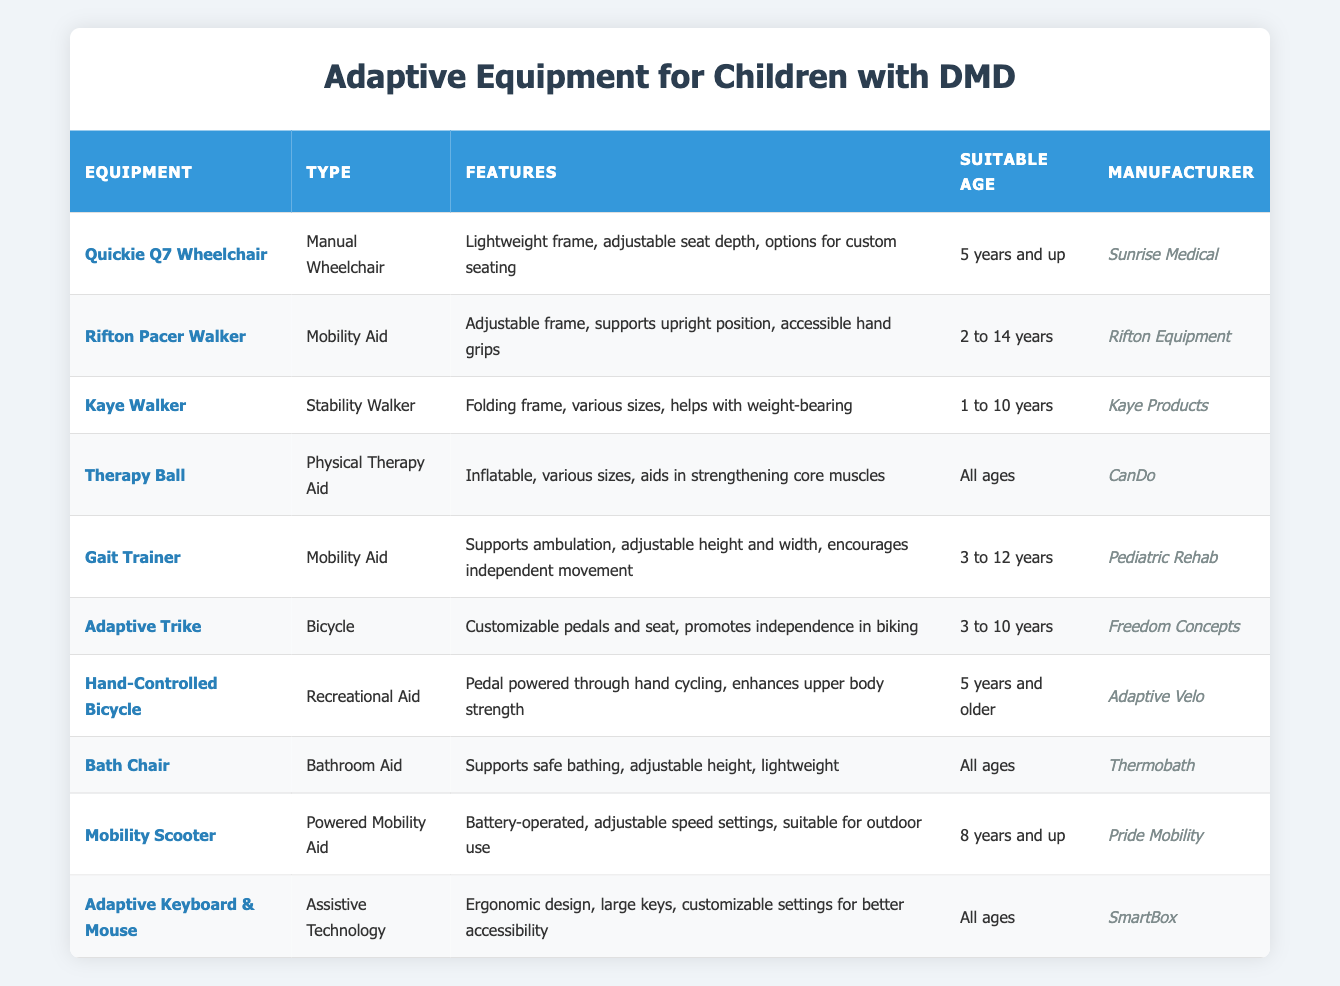What is the suitable age range for the Rifton Pacer Walker? The table indicates that the Rifton Pacer Walker is suitable for children aged 2 to 14 years. Thus, the answer is directly listed under the "Suitable Age" column for this equipment.
Answer: 2 to 14 years Which equipment is designed for all ages? By examining the "Suitable Age" column, we can see that both the Therapy Ball and Bath Chair are listed as suitable for all ages since they contain the description "All ages."
Answer: Therapy Ball, Bath Chair How many types of mobility aids are listed in the table? The table states that there are three specific types of mobility aids mentioned: Rifton Pacer Walker, Gait Trainer, and Mobility Scooter. This can be counted directly from the "Type" column.
Answer: 3 Which manufacturer produces the Adaptive Trike? The manufacturer for the Adaptive Trike is listed as Freedom Concepts under the "Manufacturer" column of the table.
Answer: Freedom Concepts Is the Quickie Q7 Wheelchair an electric or manual wheelchair? The table classifies the Quickie Q7 Wheelchair as a Manual Wheelchair in the "Type" column, confirming that it is not electric.
Answer: Manual What are the main features of the Gait Trainer? The Gait Trainer's features, as outlined in the "Features" column, include supporting ambulation and adjustable height and width, which encourages independent movement.
Answer: Supports ambulation, adjustable height and width Are there any adaptive equipment suitable for children under 5 years? Yes, by reviewing the "Suitable Age" column in the table, the Kaye Walker is suitable for ages 1 to 10 years, which includes children under 5.
Answer: Yes What is the maximum suitable age for the Adaptive Trike? The suitable age range for the Adaptive Trike is listed as 3 to 10 years, which means the maximum age is 10. This can easily be found in the "Suitable Age" column.
Answer: 10 years Which equipment has features that specifically enhance upper body strength? The Hand-Controlled Bicycle is explicitly described as enhancing upper body strength, which is stated in the "Features" column of the table.
Answer: Hand-Controlled Bicycle If a child is 7 years old, which adaptive equipment options are available? Referring to the table, the options suitable for a 7-year-old include the Rifton Pacer Walker (2 to 14), Gait Trainer (3 to 12), Adaptive Trike (3 to 10), Hand-Controlled Bicycle (5 and older), Mobility Scooter (8 and up), and Therapy Ball/Bath Chair (All ages). The overlap with suitable age defines the options.
Answer: Rifton Pacer Walker, Gait Trainer, Adaptive Trike, Hand-Controlled Bicycle, Therapy Ball, Bath Chair How many pieces of equipment are manufactured by Sunrise Medical? The table lists only one piece of equipment manufactured by Sunrise Medical, which is the Quickie Q7 Wheelchair. This is determined by looking for "Sunrise Medical" in the "Manufacturer" column.
Answer: 1 